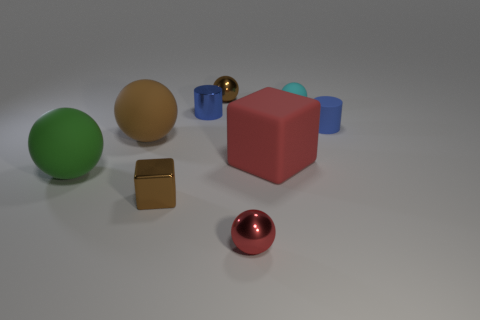Are there any objects in the scene that could be interacted with in a way not evident from their appearance? The red sphere might be more than it seems; it could possibly be a button or a dial due to its shiny, standout appearance. Interacting with it might cause something in the environment to change, such as turning on a light or opening a hidden compartment. 